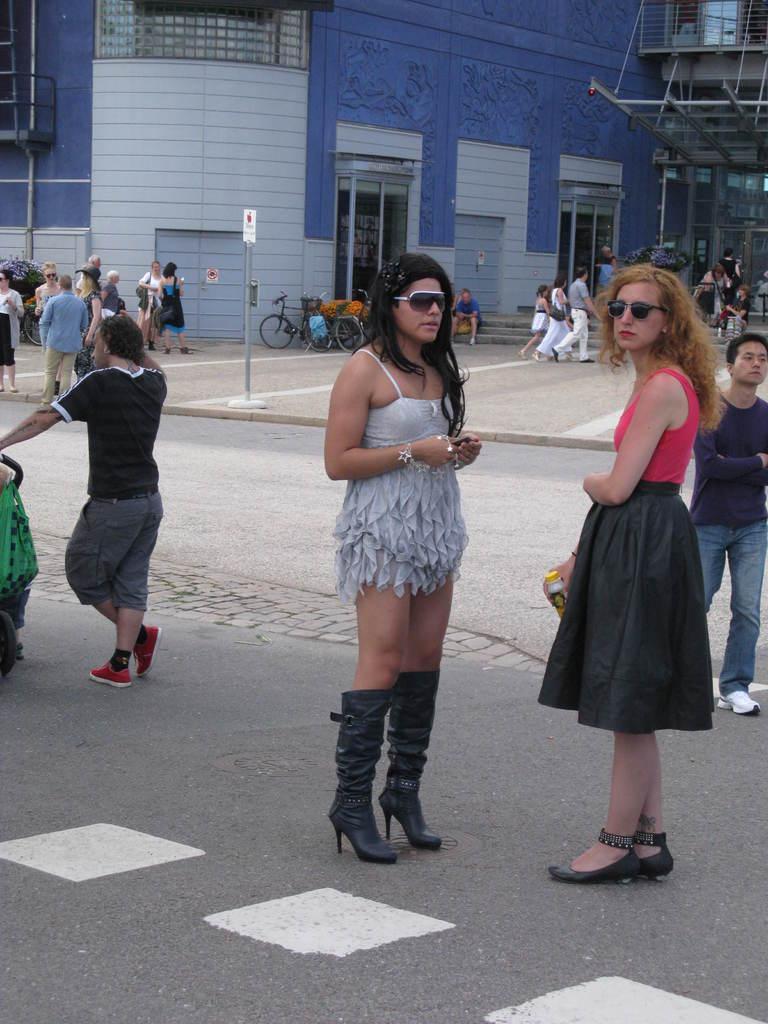How would you summarize this image in a sentence or two? In the center of the image we can see women standing on the road. On the right and left side of the image we can see persons on road. In the background we can see persons, sign board, cycles, doors, windows and building. 